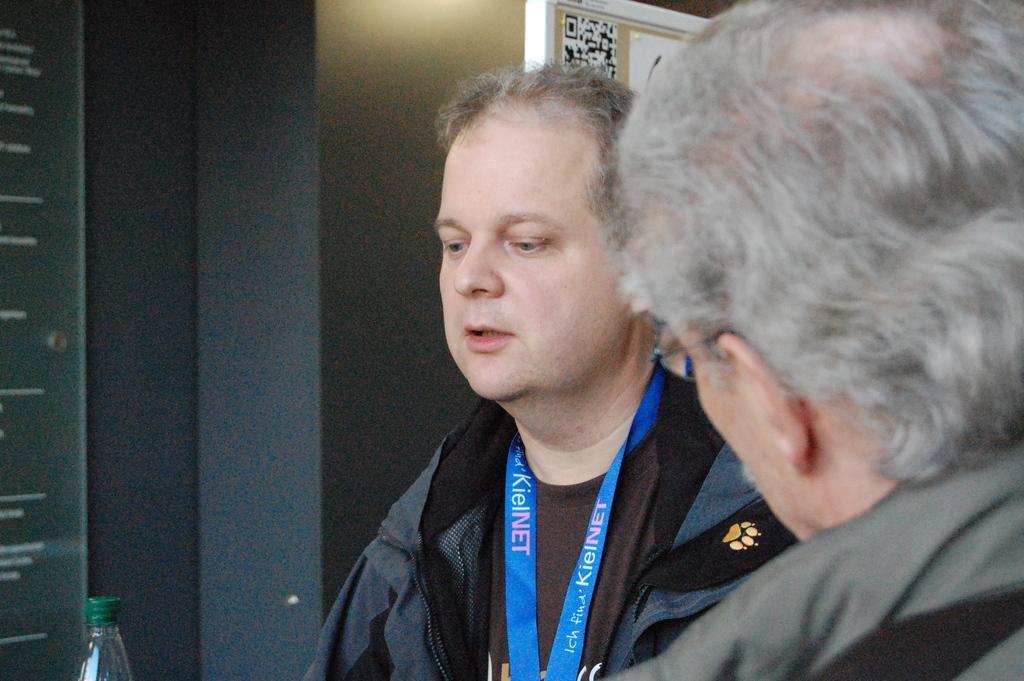Please provide a concise description of this image. In this image I can see two men and I can see both of them are wearing jackets. I can also see a man is wearing a blue colour tag around his neck. On the bottom left side of the image I can see a bottle. In the background I can see few boards and on it I can see something is written. 